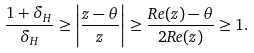Convert formula to latex. <formula><loc_0><loc_0><loc_500><loc_500>\frac { 1 + \delta _ { H } } { \delta _ { H } } \geq \left | \frac { z - \theta } { z } \right | \geq \frac { R e ( z ) - \theta } { 2 R e ( z ) } \geq 1 .</formula> 